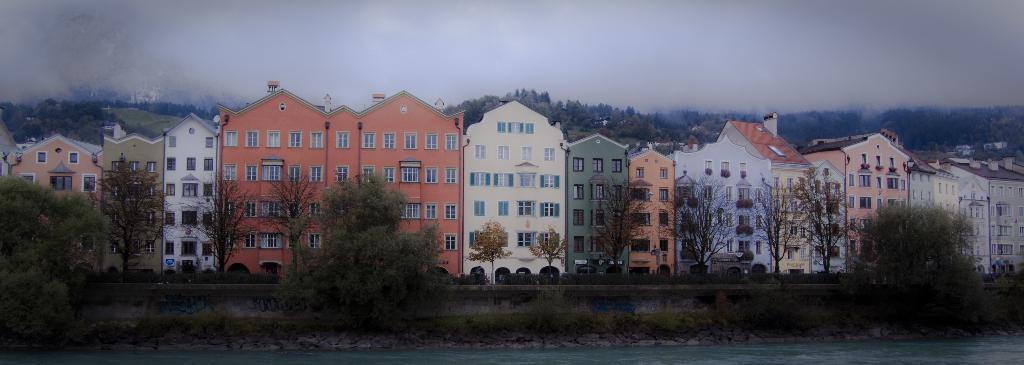What is located in front of the image? There is water in front of the image. What type of natural features can be seen in the image? There are rocks, plants, and trees in the image. What man-made structures are present in the image? There are buildings in the image. What is hanging on the wall in the image? There is a painting on a wall in the image. What is visible in the sky at the top of the image? There are clouds visible in the sky at the top of the image. How many cents are depicted in the painting on the wall in the image? There is no mention of currency or cents in the image, as it features a painting on a wall, water, rocks, plants, trees, buildings, and clouds. What type of nail is holding the painting on the wall in the image? There is no nail mentioned or visible in the image; the painting is simply hanging on the wall. 